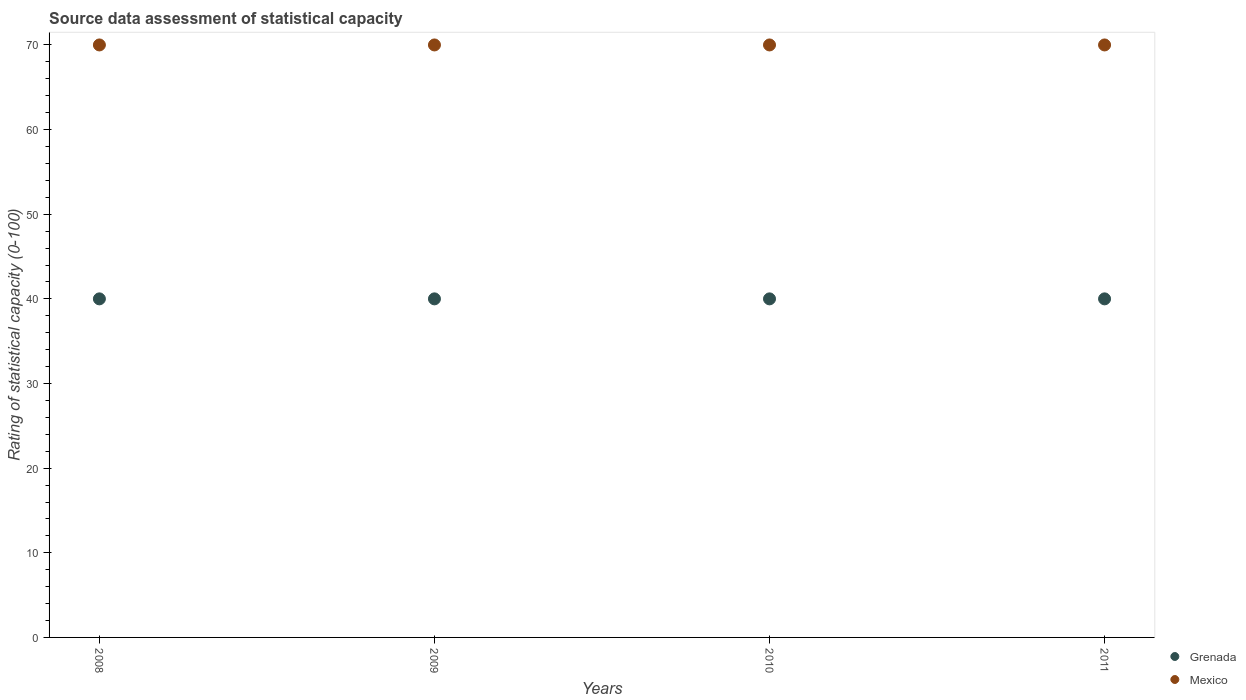How many different coloured dotlines are there?
Keep it short and to the point. 2. Is the number of dotlines equal to the number of legend labels?
Ensure brevity in your answer.  Yes. Across all years, what is the maximum rating of statistical capacity in Grenada?
Provide a succinct answer. 40. Across all years, what is the minimum rating of statistical capacity in Grenada?
Offer a very short reply. 40. In which year was the rating of statistical capacity in Mexico minimum?
Provide a succinct answer. 2008. What is the total rating of statistical capacity in Grenada in the graph?
Provide a short and direct response. 160. What is the difference between the rating of statistical capacity in Mexico in 2008 and that in 2010?
Provide a succinct answer. 0. In the year 2008, what is the difference between the rating of statistical capacity in Mexico and rating of statistical capacity in Grenada?
Provide a short and direct response. 30. What is the ratio of the rating of statistical capacity in Mexico in 2009 to that in 2011?
Your response must be concise. 1. Is the difference between the rating of statistical capacity in Mexico in 2008 and 2011 greater than the difference between the rating of statistical capacity in Grenada in 2008 and 2011?
Make the answer very short. No. What is the difference between the highest and the second highest rating of statistical capacity in Mexico?
Make the answer very short. 0. Is the rating of statistical capacity in Mexico strictly greater than the rating of statistical capacity in Grenada over the years?
Provide a short and direct response. Yes. How many dotlines are there?
Give a very brief answer. 2. How many years are there in the graph?
Keep it short and to the point. 4. What is the difference between two consecutive major ticks on the Y-axis?
Keep it short and to the point. 10. Are the values on the major ticks of Y-axis written in scientific E-notation?
Give a very brief answer. No. Does the graph contain any zero values?
Your answer should be very brief. No. Where does the legend appear in the graph?
Your response must be concise. Bottom right. How many legend labels are there?
Keep it short and to the point. 2. What is the title of the graph?
Give a very brief answer. Source data assessment of statistical capacity. What is the label or title of the Y-axis?
Your response must be concise. Rating of statistical capacity (0-100). What is the Rating of statistical capacity (0-100) in Grenada in 2008?
Your response must be concise. 40. What is the Rating of statistical capacity (0-100) in Mexico in 2008?
Offer a very short reply. 70. What is the Rating of statistical capacity (0-100) in Grenada in 2009?
Keep it short and to the point. 40. What is the Rating of statistical capacity (0-100) of Mexico in 2009?
Your answer should be very brief. 70. What is the Rating of statistical capacity (0-100) in Grenada in 2010?
Keep it short and to the point. 40. What is the Rating of statistical capacity (0-100) of Mexico in 2010?
Provide a succinct answer. 70. What is the Rating of statistical capacity (0-100) in Grenada in 2011?
Keep it short and to the point. 40. Across all years, what is the maximum Rating of statistical capacity (0-100) in Grenada?
Make the answer very short. 40. Across all years, what is the minimum Rating of statistical capacity (0-100) in Mexico?
Your response must be concise. 70. What is the total Rating of statistical capacity (0-100) in Grenada in the graph?
Offer a very short reply. 160. What is the total Rating of statistical capacity (0-100) of Mexico in the graph?
Offer a very short reply. 280. What is the difference between the Rating of statistical capacity (0-100) of Grenada in 2008 and that in 2009?
Make the answer very short. 0. What is the difference between the Rating of statistical capacity (0-100) in Grenada in 2008 and that in 2010?
Make the answer very short. 0. What is the difference between the Rating of statistical capacity (0-100) of Mexico in 2008 and that in 2010?
Keep it short and to the point. 0. What is the difference between the Rating of statistical capacity (0-100) in Mexico in 2008 and that in 2011?
Make the answer very short. 0. What is the difference between the Rating of statistical capacity (0-100) of Grenada in 2009 and that in 2011?
Your answer should be compact. 0. What is the difference between the Rating of statistical capacity (0-100) in Grenada in 2008 and the Rating of statistical capacity (0-100) in Mexico in 2009?
Keep it short and to the point. -30. What is the difference between the Rating of statistical capacity (0-100) in Grenada in 2008 and the Rating of statistical capacity (0-100) in Mexico in 2010?
Provide a succinct answer. -30. What is the difference between the Rating of statistical capacity (0-100) in Grenada in 2009 and the Rating of statistical capacity (0-100) in Mexico in 2011?
Provide a short and direct response. -30. In the year 2008, what is the difference between the Rating of statistical capacity (0-100) of Grenada and Rating of statistical capacity (0-100) of Mexico?
Keep it short and to the point. -30. What is the ratio of the Rating of statistical capacity (0-100) in Mexico in 2008 to that in 2009?
Your answer should be very brief. 1. What is the ratio of the Rating of statistical capacity (0-100) in Grenada in 2008 to that in 2010?
Give a very brief answer. 1. What is the ratio of the Rating of statistical capacity (0-100) in Mexico in 2008 to that in 2010?
Provide a succinct answer. 1. What is the ratio of the Rating of statistical capacity (0-100) of Grenada in 2008 to that in 2011?
Make the answer very short. 1. What is the ratio of the Rating of statistical capacity (0-100) of Grenada in 2010 to that in 2011?
Your response must be concise. 1. What is the ratio of the Rating of statistical capacity (0-100) in Mexico in 2010 to that in 2011?
Give a very brief answer. 1. 